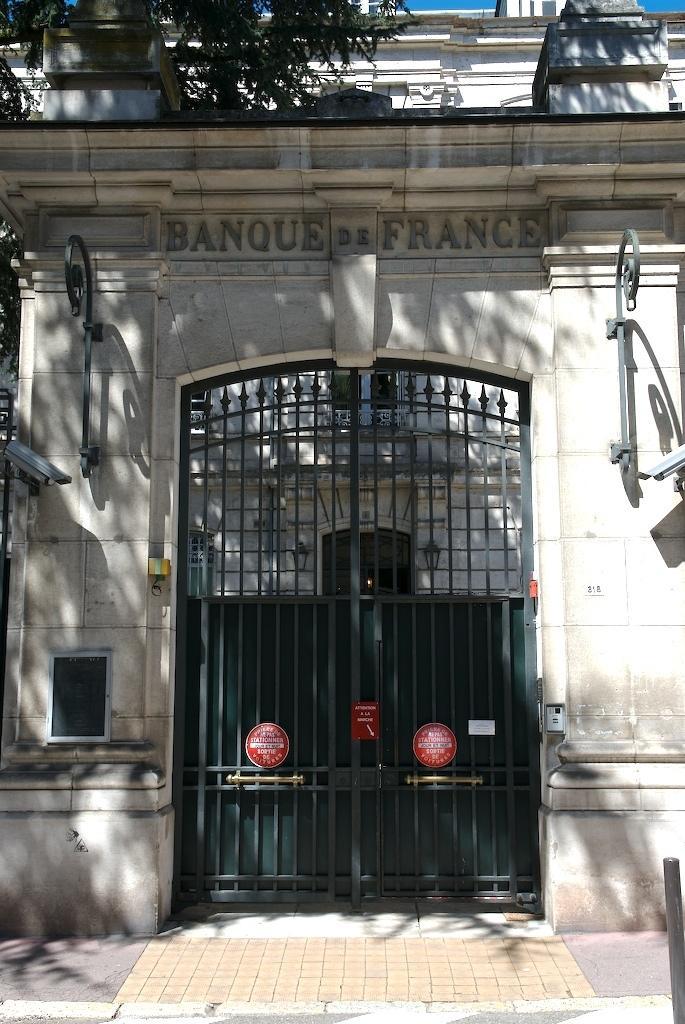How would you summarize this image in a sentence or two? In this image we can see a building with a metal gate and some text on a wall. On the top of the image we can see a tree and the sky. 